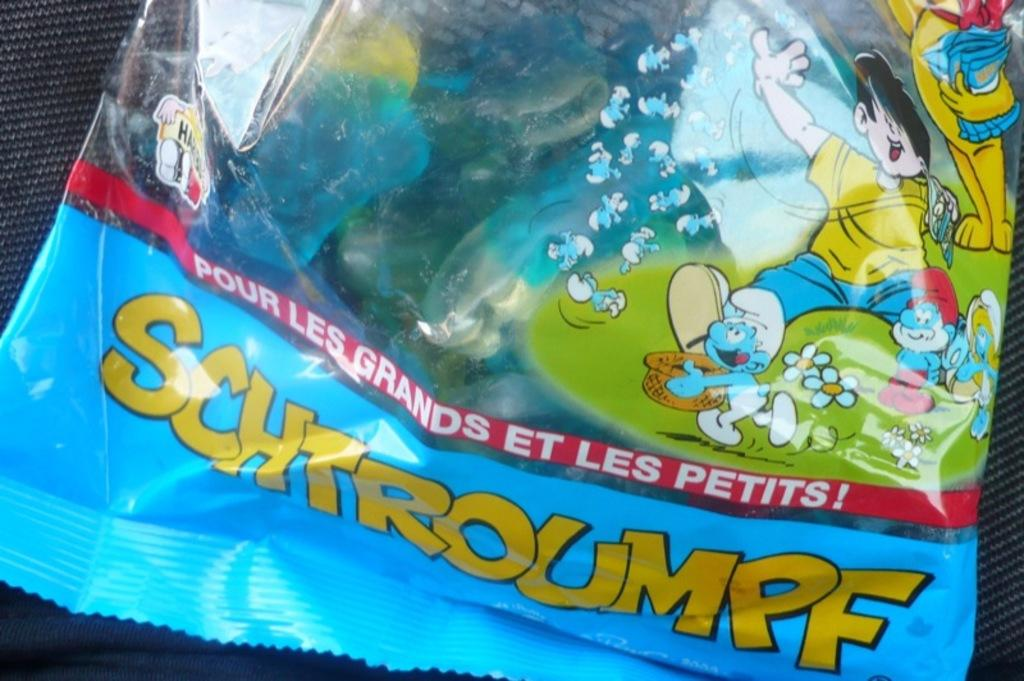What is the color of the packet in the image? The packet in the image is blue. What can be seen written on the packet? There is a yellow color word on the packet. What type of illustrations are present on the packet? There are cartoon pictures on the right side of the packet. What type of meal is being prepared in the image? There is no meal preparation visible in the image; it only shows a blue color packet with a yellow color word and cartoon pictures. Can you describe the flame coming from the industry in the image? There is no industry or flame present in the image; it only features a blue color packet with a yellow color word and cartoon pictures. 